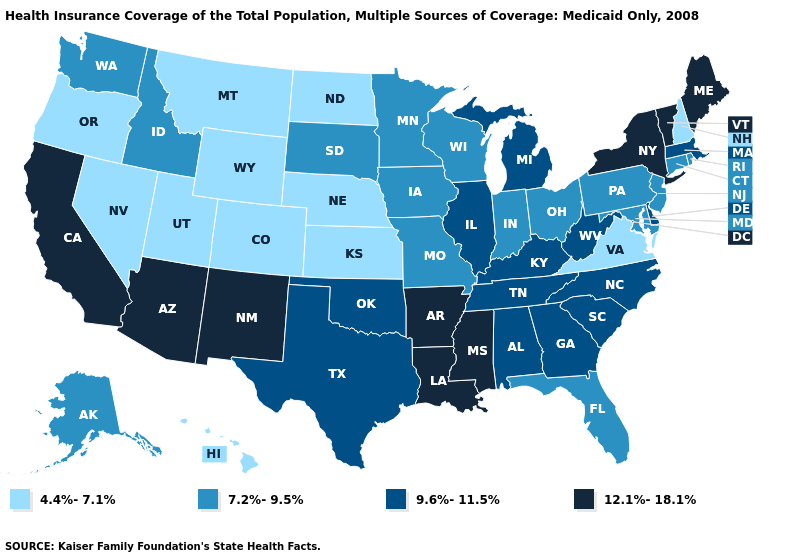What is the highest value in the South ?
Be succinct. 12.1%-18.1%. Name the states that have a value in the range 9.6%-11.5%?
Be succinct. Alabama, Delaware, Georgia, Illinois, Kentucky, Massachusetts, Michigan, North Carolina, Oklahoma, South Carolina, Tennessee, Texas, West Virginia. What is the value of South Carolina?
Short answer required. 9.6%-11.5%. What is the lowest value in the USA?
Keep it brief. 4.4%-7.1%. What is the value of Arkansas?
Short answer required. 12.1%-18.1%. Does the map have missing data?
Give a very brief answer. No. How many symbols are there in the legend?
Answer briefly. 4. Name the states that have a value in the range 7.2%-9.5%?
Answer briefly. Alaska, Connecticut, Florida, Idaho, Indiana, Iowa, Maryland, Minnesota, Missouri, New Jersey, Ohio, Pennsylvania, Rhode Island, South Dakota, Washington, Wisconsin. Does Pennsylvania have the highest value in the USA?
Keep it brief. No. What is the lowest value in the South?
Concise answer only. 4.4%-7.1%. What is the lowest value in the USA?
Concise answer only. 4.4%-7.1%. What is the value of Mississippi?
Write a very short answer. 12.1%-18.1%. Among the states that border New York , which have the lowest value?
Give a very brief answer. Connecticut, New Jersey, Pennsylvania. What is the lowest value in the West?
Keep it brief. 4.4%-7.1%. Among the states that border New Mexico , does Arizona have the lowest value?
Keep it brief. No. 